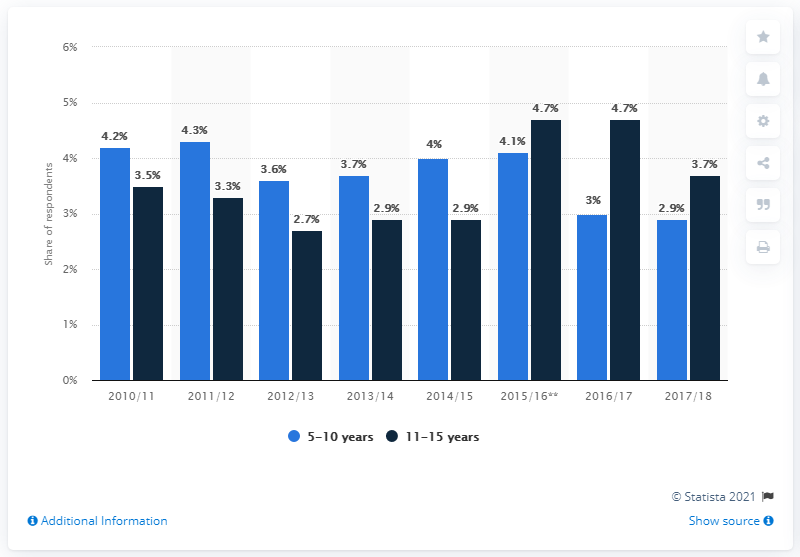Give some essential details in this illustration. In the 4 weeks leading up to the survey, 3.7% of children between the ages of 11 and 15 had participated in horse riding or pony trekking. 